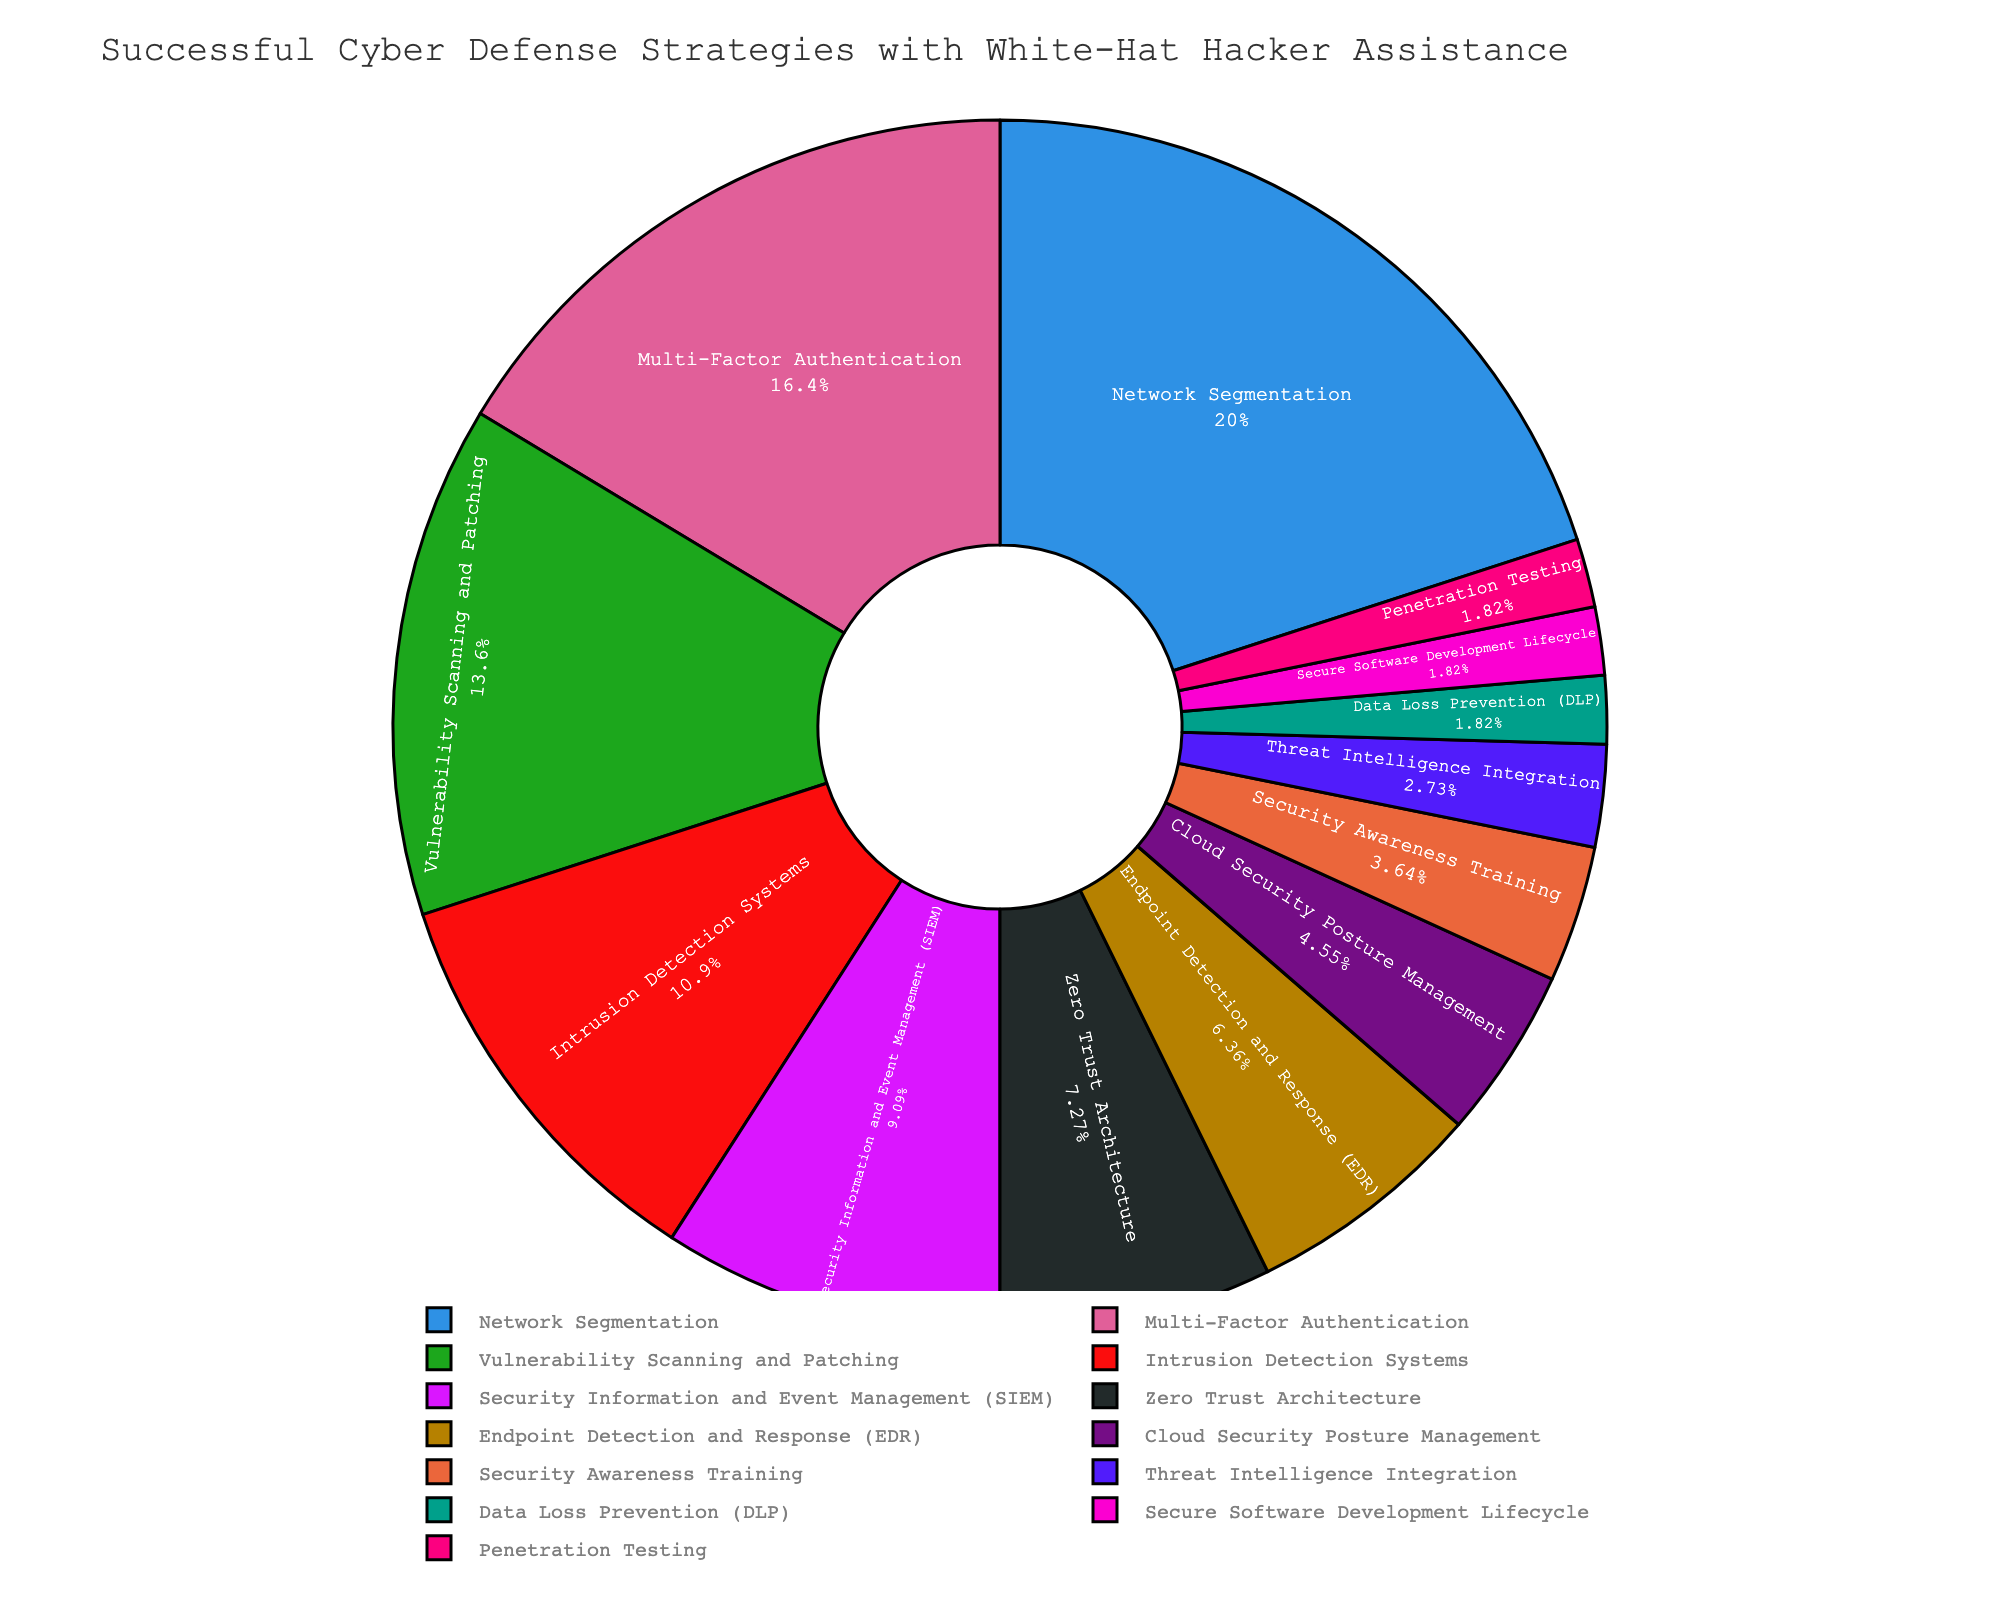Which strategy has the highest percentage in the successful cyber defense strategies implemented with white-hat hacker assistance? To find this, look at the labels in the pie chart and identify the strategy with the largest slice. Network Segmentation is the largest section in the pie chart.
Answer: Network Segmentation What is the combined percentage of Multi-Factor Authentication and Intrusion Detection Systems? Add the percentages of Multi-Factor Authentication (18%) and Intrusion Detection Systems (12%). 18 + 12 = 30.
Answer: 30% Which two strategies have the smallest percentage on the pie chart? Look for the smallest slices in the pie chart. The two smallest slices correspond to Data Loss Prevention (DLP) and Secure Software Development Lifecycle, each with 2%.
Answer: Data Loss Prevention (DLP) and Secure Software Development Lifecycle How does the percentage of Vulnerability Scanning and Patching compare to Endpoint Detection and Response (EDR)? Compare the percentages of Vulnerability Scanning and Patching (15%) and Endpoint Detection and Response (7%). Since 15 is greater than 7, Vulnerability Scanning and Patching has a higher percentage than Endpoint Detection and Response.
Answer: Vulnerability Scanning and Patching has a higher percentage than Endpoint Detection and Response What percentage of the successful strategies involves Security Information and Event Management (SIEM) and Zero Trust Architecture combined? Add the percentages of Security Information and Event Management (SIEM) (10%) and Zero Trust Architecture (8%). 10 + 8 = 18.
Answer: 18% Which strategy is represented by the third-largest slice in the pie chart? Identify the third-largest slice by comparing the sizes visually. The third largest percentage is Vulnerability Scanning and Patching, with 15%.
Answer: Vulnerability Scanning and Patching Which strategy has a larger percentage: Cloud Security Posture Management or Security Awareness Training? Compare the percentages associated with Cloud Security Posture Management (5%) and Security Awareness Training (4%). Since 5 is greater than 4, Cloud Security Posture Management has a larger percentage.
Answer: Cloud Security Posture Management What is the difference in percentage between Network Segmentation and Penetration Testing? Subtract the Penetration Testing percentage (2%) from the Network Segmentation percentage (22%). 22 - 2 = 20.
Answer: 20% How many strategies have a percentage greater than 7%? Count the number of strategies in the pie chart that have slices representing more than 7%. Specifically, Network Segmentation (22%), Multi-Factor Authentication (18%), Vulnerability Scanning and Patching (15%), Intrusion Detection Systems (12%), Security Information and Event Management (SIEM) (10%), and Zero Trust Architecture (8%).
Answer: 6 What is the total percentage of all strategies combined? Since the pie chart represents the total distribution, all the percentages should sum up to 100%.
Answer: 100% 